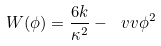Convert formula to latex. <formula><loc_0><loc_0><loc_500><loc_500>W ( \phi ) = \frac { 6 k } { \kappa ^ { 2 } } - \ v v \phi ^ { 2 }</formula> 